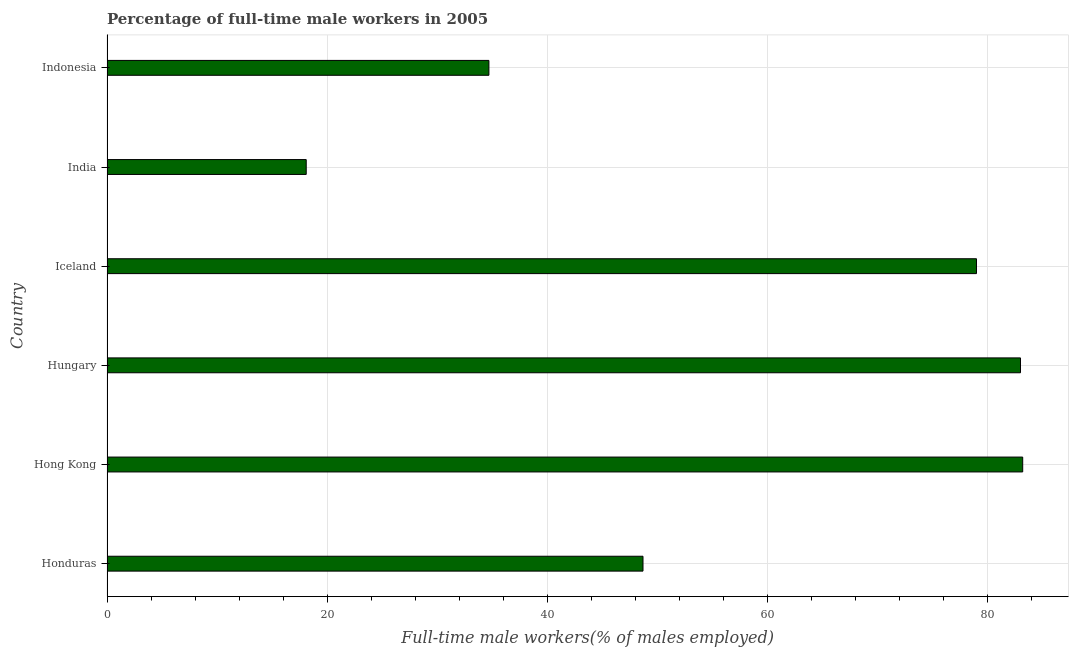Does the graph contain any zero values?
Ensure brevity in your answer.  No. What is the title of the graph?
Give a very brief answer. Percentage of full-time male workers in 2005. What is the label or title of the X-axis?
Offer a terse response. Full-time male workers(% of males employed). What is the label or title of the Y-axis?
Your answer should be compact. Country. What is the percentage of full-time male workers in India?
Keep it short and to the point. 18.1. Across all countries, what is the maximum percentage of full-time male workers?
Provide a succinct answer. 83.2. Across all countries, what is the minimum percentage of full-time male workers?
Keep it short and to the point. 18.1. In which country was the percentage of full-time male workers maximum?
Provide a short and direct response. Hong Kong. In which country was the percentage of full-time male workers minimum?
Make the answer very short. India. What is the sum of the percentage of full-time male workers?
Make the answer very short. 346.7. What is the difference between the percentage of full-time male workers in Hong Kong and Iceland?
Make the answer very short. 4.2. What is the average percentage of full-time male workers per country?
Keep it short and to the point. 57.78. What is the median percentage of full-time male workers?
Provide a short and direct response. 63.85. What is the ratio of the percentage of full-time male workers in Hungary to that in Indonesia?
Provide a succinct answer. 2.39. Is the percentage of full-time male workers in Iceland less than that in Indonesia?
Provide a short and direct response. No. Is the difference between the percentage of full-time male workers in Hungary and Indonesia greater than the difference between any two countries?
Your response must be concise. No. What is the difference between the highest and the second highest percentage of full-time male workers?
Keep it short and to the point. 0.2. Is the sum of the percentage of full-time male workers in Hungary and Indonesia greater than the maximum percentage of full-time male workers across all countries?
Your answer should be very brief. Yes. What is the difference between the highest and the lowest percentage of full-time male workers?
Offer a terse response. 65.1. In how many countries, is the percentage of full-time male workers greater than the average percentage of full-time male workers taken over all countries?
Keep it short and to the point. 3. How many bars are there?
Offer a terse response. 6. How many countries are there in the graph?
Your response must be concise. 6. Are the values on the major ticks of X-axis written in scientific E-notation?
Make the answer very short. No. What is the Full-time male workers(% of males employed) of Honduras?
Offer a very short reply. 48.7. What is the Full-time male workers(% of males employed) of Hong Kong?
Keep it short and to the point. 83.2. What is the Full-time male workers(% of males employed) in Hungary?
Your response must be concise. 83. What is the Full-time male workers(% of males employed) in Iceland?
Offer a very short reply. 79. What is the Full-time male workers(% of males employed) in India?
Provide a short and direct response. 18.1. What is the Full-time male workers(% of males employed) in Indonesia?
Your answer should be compact. 34.7. What is the difference between the Full-time male workers(% of males employed) in Honduras and Hong Kong?
Keep it short and to the point. -34.5. What is the difference between the Full-time male workers(% of males employed) in Honduras and Hungary?
Offer a very short reply. -34.3. What is the difference between the Full-time male workers(% of males employed) in Honduras and Iceland?
Offer a very short reply. -30.3. What is the difference between the Full-time male workers(% of males employed) in Honduras and India?
Your answer should be very brief. 30.6. What is the difference between the Full-time male workers(% of males employed) in Hong Kong and Hungary?
Your answer should be very brief. 0.2. What is the difference between the Full-time male workers(% of males employed) in Hong Kong and India?
Provide a succinct answer. 65.1. What is the difference between the Full-time male workers(% of males employed) in Hong Kong and Indonesia?
Your answer should be compact. 48.5. What is the difference between the Full-time male workers(% of males employed) in Hungary and Iceland?
Your answer should be compact. 4. What is the difference between the Full-time male workers(% of males employed) in Hungary and India?
Keep it short and to the point. 64.9. What is the difference between the Full-time male workers(% of males employed) in Hungary and Indonesia?
Provide a succinct answer. 48.3. What is the difference between the Full-time male workers(% of males employed) in Iceland and India?
Offer a terse response. 60.9. What is the difference between the Full-time male workers(% of males employed) in Iceland and Indonesia?
Provide a succinct answer. 44.3. What is the difference between the Full-time male workers(% of males employed) in India and Indonesia?
Give a very brief answer. -16.6. What is the ratio of the Full-time male workers(% of males employed) in Honduras to that in Hong Kong?
Your response must be concise. 0.58. What is the ratio of the Full-time male workers(% of males employed) in Honduras to that in Hungary?
Give a very brief answer. 0.59. What is the ratio of the Full-time male workers(% of males employed) in Honduras to that in Iceland?
Your answer should be very brief. 0.62. What is the ratio of the Full-time male workers(% of males employed) in Honduras to that in India?
Give a very brief answer. 2.69. What is the ratio of the Full-time male workers(% of males employed) in Honduras to that in Indonesia?
Your answer should be very brief. 1.4. What is the ratio of the Full-time male workers(% of males employed) in Hong Kong to that in Hungary?
Your answer should be compact. 1. What is the ratio of the Full-time male workers(% of males employed) in Hong Kong to that in Iceland?
Your answer should be compact. 1.05. What is the ratio of the Full-time male workers(% of males employed) in Hong Kong to that in India?
Ensure brevity in your answer.  4.6. What is the ratio of the Full-time male workers(% of males employed) in Hong Kong to that in Indonesia?
Offer a terse response. 2.4. What is the ratio of the Full-time male workers(% of males employed) in Hungary to that in Iceland?
Offer a very short reply. 1.05. What is the ratio of the Full-time male workers(% of males employed) in Hungary to that in India?
Offer a terse response. 4.59. What is the ratio of the Full-time male workers(% of males employed) in Hungary to that in Indonesia?
Offer a terse response. 2.39. What is the ratio of the Full-time male workers(% of males employed) in Iceland to that in India?
Your answer should be very brief. 4.37. What is the ratio of the Full-time male workers(% of males employed) in Iceland to that in Indonesia?
Your response must be concise. 2.28. What is the ratio of the Full-time male workers(% of males employed) in India to that in Indonesia?
Keep it short and to the point. 0.52. 